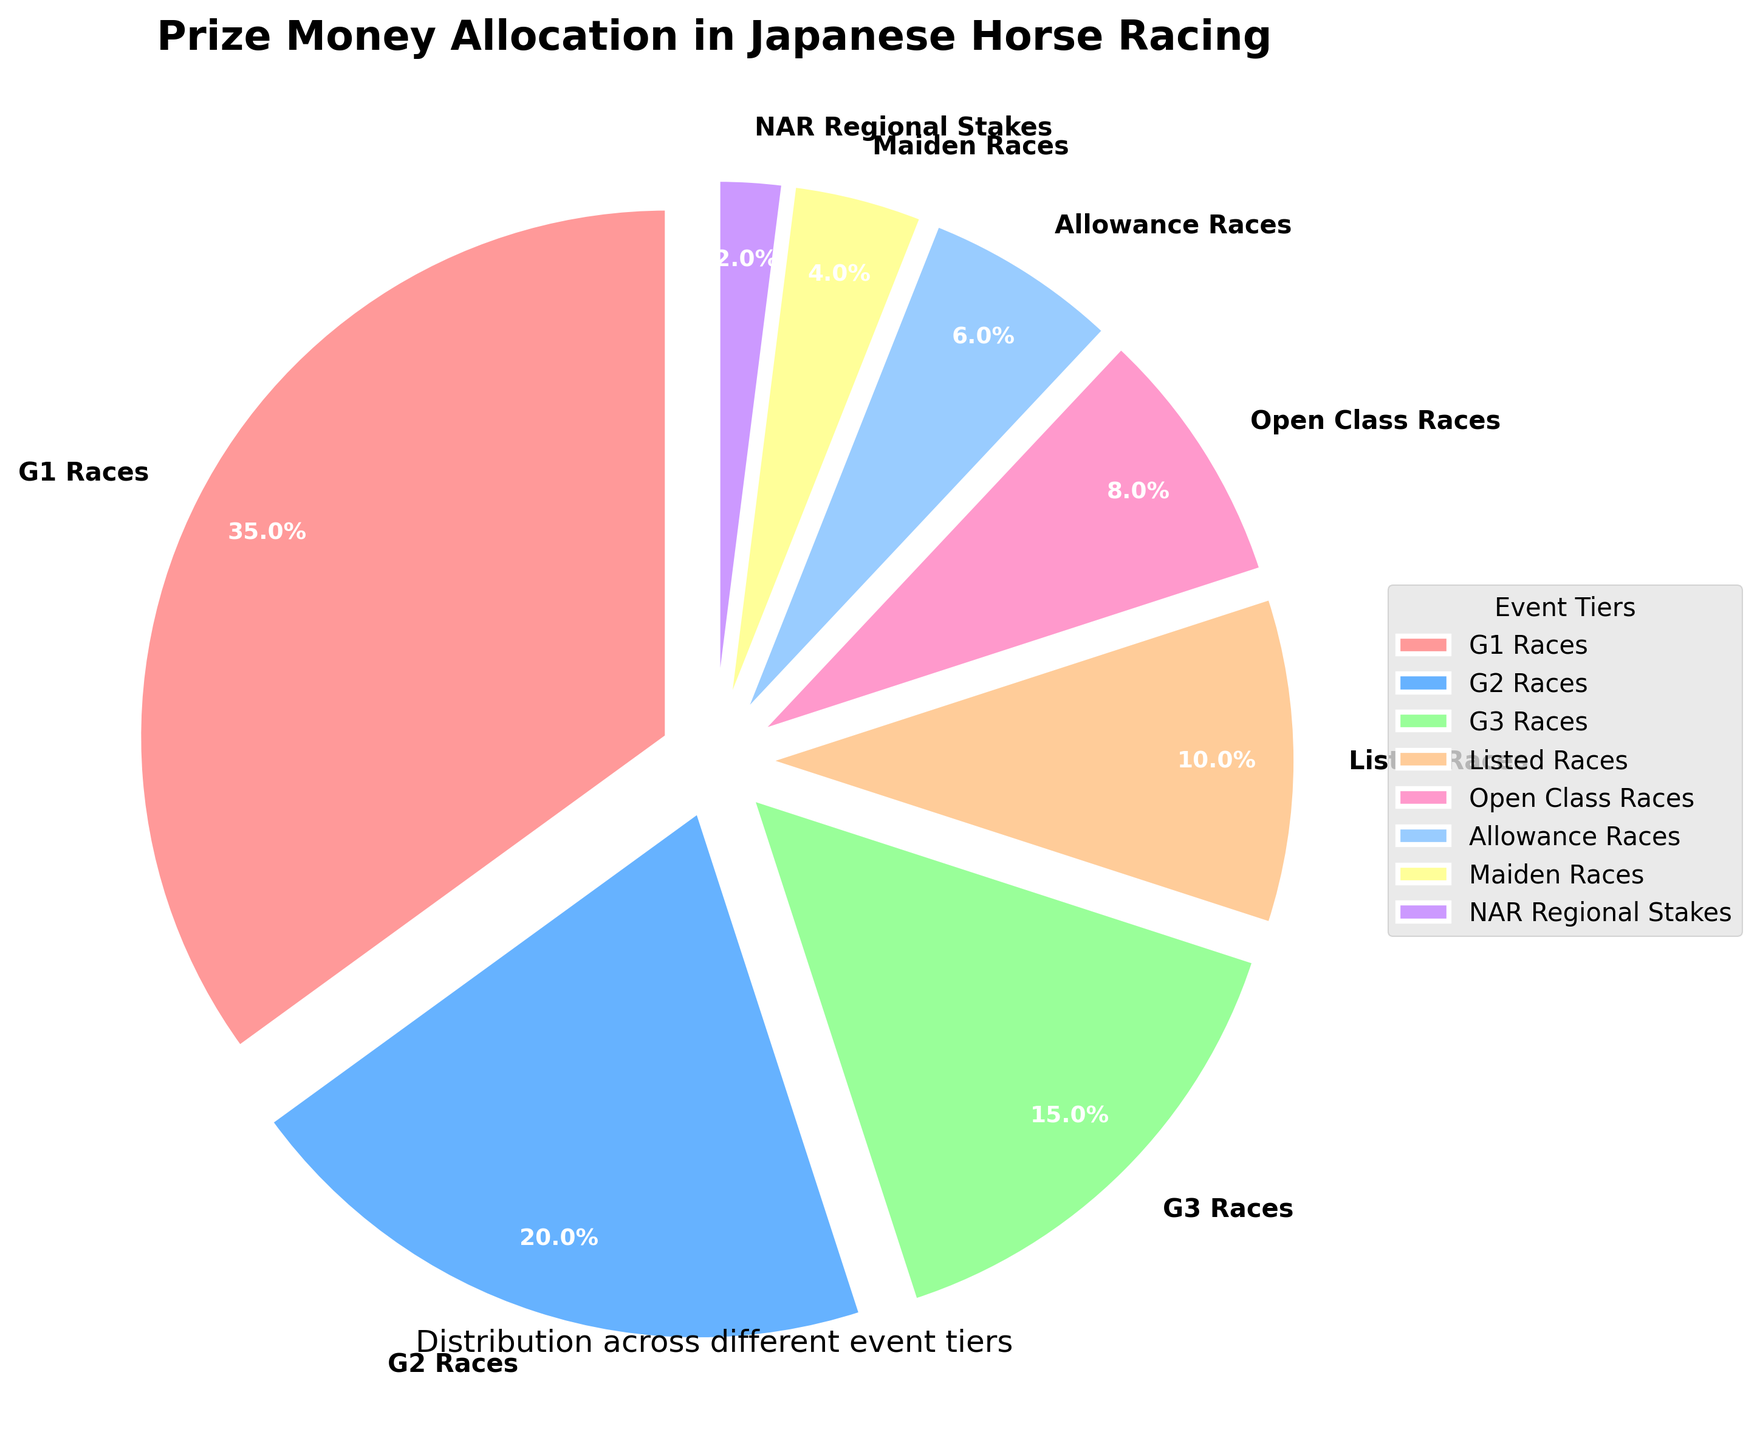Which tier receives the highest allocation of prize money? By looking at the chart, you can see that the largest slice represents the G1 Races tier with 35% of the total allocation. The label and percentage displayed directly beside each slice also confirm this.
Answer: G1 Races How much more prize money is allocated to G2 Races compared to Maiden Races? The G2 Races allocate 20% of the prize money, while Maiden Races allocate 4%. The difference is calculated as 20% - 4%.
Answer: 16% Which tier accounts for the smallest allocation of prize money? The smallest slice on the pie chart corresponds to the NAR Regional Stakes tier with 2% of the total allocation. This is confirmed by the label next to the smallest slice.
Answer: NAR Regional Stakes What is the combined prize money allocation for G1 and G2 Races? G1 Races allocate 35% and G2 Races allocate 20%. Adding these percentages together gives 35% + 20%.
Answer: 55% Is the prize money allocation for Listed Races greater than that for Allowance Races? The pie chart shows that Listed Races allocate 10% of the prize money, while Allowance Races allocate 6%. Comparing these values, 10% is indeed greater than 6%.
Answer: Yes By how much does the allocation for Open Class Races exceed that for NAR Regional Stakes? Open Class Races allocate 8%, and NAR Regional Stakes allocate 2%. The difference is calculated as 8% - 2%.
Answer: 6% Which color represents the G3 Races tier? The G3 Races tier is represented by the green slice on the pie chart. This can be confirmed by matching the label for G3 Races to the corresponding color in the pie chart.
Answer: Green What's the total prize money allocation for events categorized below G3 Races? Adding the percentages for Listed Races (10%), Open Class Races (8%), Allowance Races (6%), Maiden Races (4%), and NAR Regional Stakes (2%) gives 10% + 8% + 6% + 4% + 2%.
Answer: 30% Are the allocations for G1, G2, and G3 Races more than 50% of the total prize money? Summing the percentages for G1 (35%), G2 (20%), and G3 Races (15%) gives 35% + 20% + 15%. Since this equals 70%, which is more than 50%, the answer is yes.
Answer: Yes What is the percentage gap between the tier with the highest allocation and the second-highest allocation? The G1 Races have the highest allocation at 35%, and the G2 Races have the second-highest at 20%. The gap is calculated as 35% - 20%.
Answer: 15% 